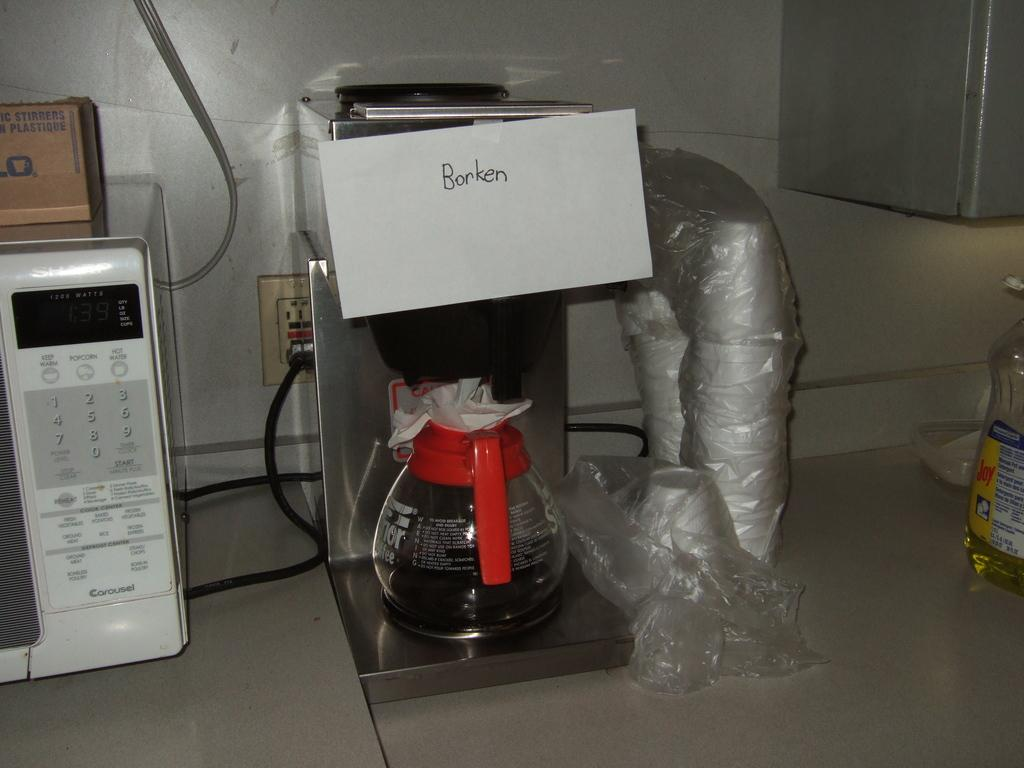<image>
Create a compact narrative representing the image presented. A "broken" sign is taped to the coffee maker. 